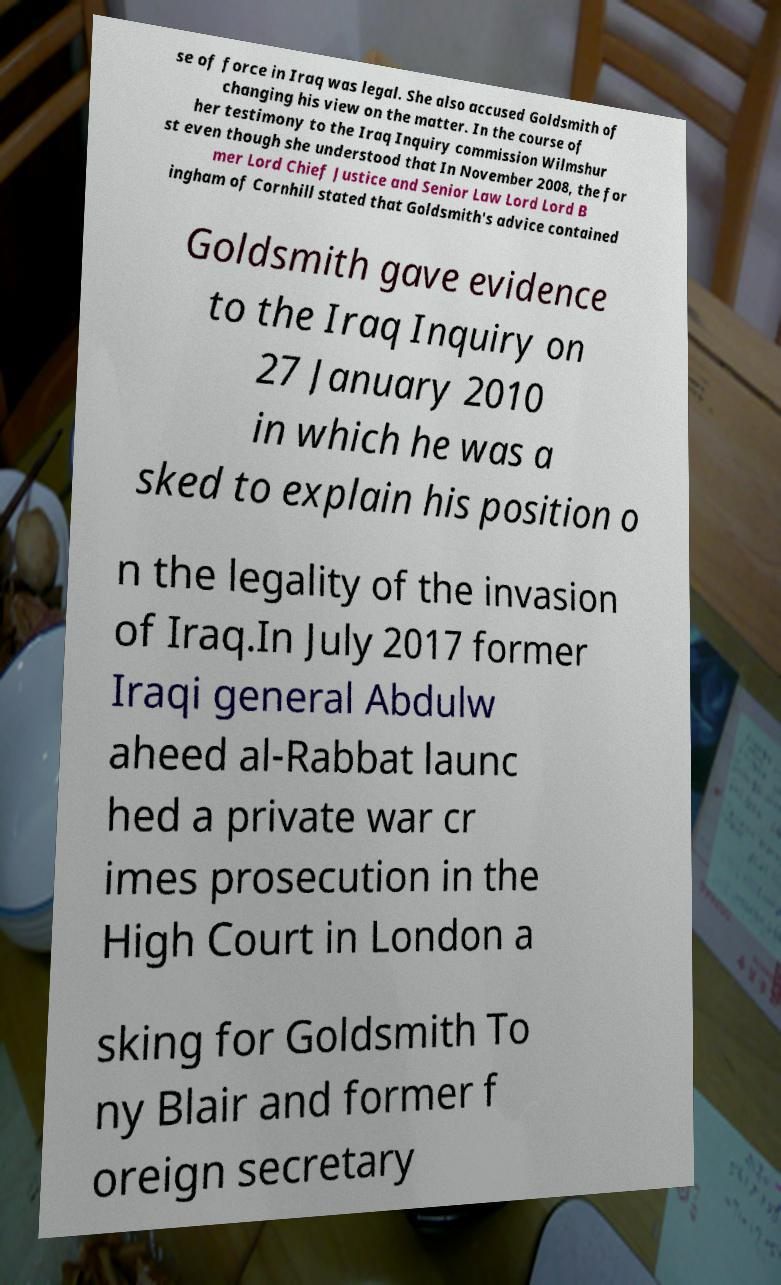There's text embedded in this image that I need extracted. Can you transcribe it verbatim? se of force in Iraq was legal. She also accused Goldsmith of changing his view on the matter. In the course of her testimony to the Iraq Inquiry commission Wilmshur st even though she understood that In November 2008, the for mer Lord Chief Justice and Senior Law Lord Lord B ingham of Cornhill stated that Goldsmith's advice contained Goldsmith gave evidence to the Iraq Inquiry on 27 January 2010 in which he was a sked to explain his position o n the legality of the invasion of Iraq.In July 2017 former Iraqi general Abdulw aheed al-Rabbat launc hed a private war cr imes prosecution in the High Court in London a sking for Goldsmith To ny Blair and former f oreign secretary 